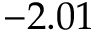<formula> <loc_0><loc_0><loc_500><loc_500>- 2 . 0 1</formula> 